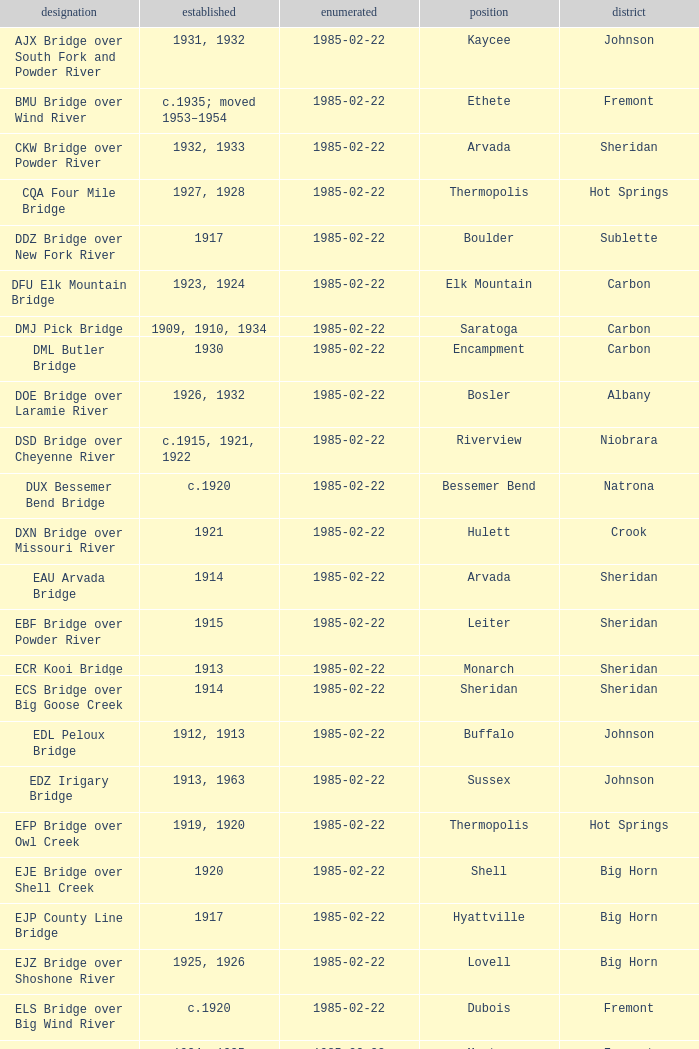Can you parse all the data within this table? {'header': ['designation', 'established', 'enumerated', 'position', 'district'], 'rows': [['AJX Bridge over South Fork and Powder River', '1931, 1932', '1985-02-22', 'Kaycee', 'Johnson'], ['BMU Bridge over Wind River', 'c.1935; moved 1953–1954', '1985-02-22', 'Ethete', 'Fremont'], ['CKW Bridge over Powder River', '1932, 1933', '1985-02-22', 'Arvada', 'Sheridan'], ['CQA Four Mile Bridge', '1927, 1928', '1985-02-22', 'Thermopolis', 'Hot Springs'], ['DDZ Bridge over New Fork River', '1917', '1985-02-22', 'Boulder', 'Sublette'], ['DFU Elk Mountain Bridge', '1923, 1924', '1985-02-22', 'Elk Mountain', 'Carbon'], ['DMJ Pick Bridge', '1909, 1910, 1934', '1985-02-22', 'Saratoga', 'Carbon'], ['DML Butler Bridge', '1930', '1985-02-22', 'Encampment', 'Carbon'], ['DOE Bridge over Laramie River', '1926, 1932', '1985-02-22', 'Bosler', 'Albany'], ['DSD Bridge over Cheyenne River', 'c.1915, 1921, 1922', '1985-02-22', 'Riverview', 'Niobrara'], ['DUX Bessemer Bend Bridge', 'c.1920', '1985-02-22', 'Bessemer Bend', 'Natrona'], ['DXN Bridge over Missouri River', '1921', '1985-02-22', 'Hulett', 'Crook'], ['EAU Arvada Bridge', '1914', '1985-02-22', 'Arvada', 'Sheridan'], ['EBF Bridge over Powder River', '1915', '1985-02-22', 'Leiter', 'Sheridan'], ['ECR Kooi Bridge', '1913', '1985-02-22', 'Monarch', 'Sheridan'], ['ECS Bridge over Big Goose Creek', '1914', '1985-02-22', 'Sheridan', 'Sheridan'], ['EDL Peloux Bridge', '1912, 1913', '1985-02-22', 'Buffalo', 'Johnson'], ['EDZ Irigary Bridge', '1913, 1963', '1985-02-22', 'Sussex', 'Johnson'], ['EFP Bridge over Owl Creek', '1919, 1920', '1985-02-22', 'Thermopolis', 'Hot Springs'], ['EJE Bridge over Shell Creek', '1920', '1985-02-22', 'Shell', 'Big Horn'], ['EJP County Line Bridge', '1917', '1985-02-22', 'Hyattville', 'Big Horn'], ['EJZ Bridge over Shoshone River', '1925, 1926', '1985-02-22', 'Lovell', 'Big Horn'], ['ELS Bridge over Big Wind River', 'c.1920', '1985-02-22', 'Dubois', 'Fremont'], ['ELY Wind River Diversion Dam Bridge', '1924, 1925', '1985-02-22', 'Morton', 'Fremont'], ['ENP Bridge over Green River', 'c.1905', '1985-02-22', 'Daniel', 'Sublette'], ["ERT Bridge over Black's Fork", 'c.1920', '1985-02-22', 'Fort Bridger', 'Uinta'], ['ETD Bridge over Green River', '1913', '1985-02-22', 'Fontenelle', 'Sweetwater'], ['ETR Big Island Bridge', '1909, 1910', '1985-02-22', 'Green River', 'Sweetwater'], ['EWZ Bridge over East Channel of Laramie River', '1913, 1914', '1985-02-22', 'Wheatland', 'Platte'], ['Hayden Arch Bridge', '1924, 1925', '1985-02-22', 'Cody', 'Park'], ['Rairden Bridge', '1916', '1985-02-22', 'Manderson', 'Big Horn']]} Which bridge in sheridan county was erected in 1915? EBF Bridge over Powder River. 